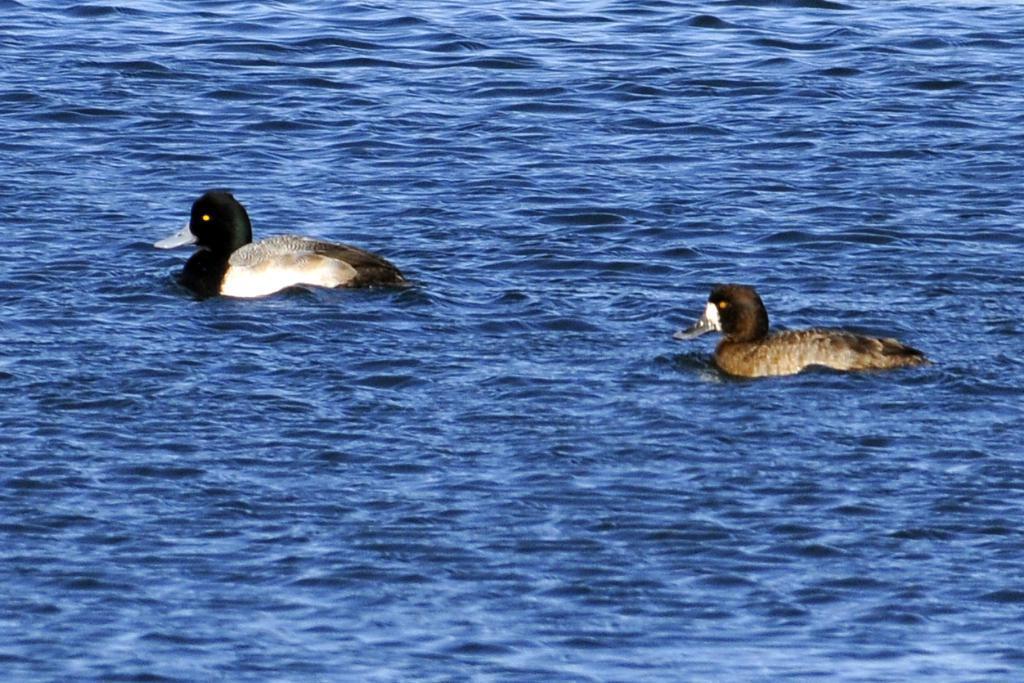In one or two sentences, can you explain what this image depicts? In this picture, we see two ducks are swimming in the water. Here, we see the water and this water might be in the river. 